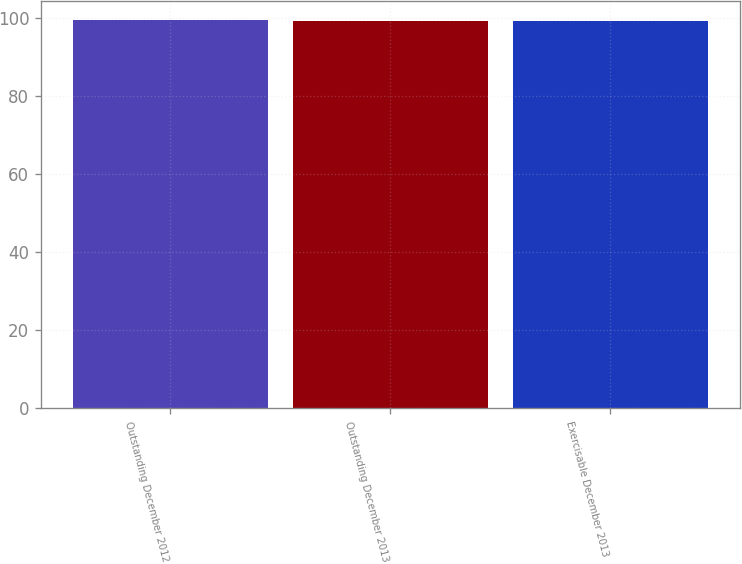Convert chart to OTSL. <chart><loc_0><loc_0><loc_500><loc_500><bar_chart><fcel>Outstanding December 2012<fcel>Outstanding December 2013<fcel>Exercisable December 2013<nl><fcel>99.51<fcel>99.37<fcel>99.38<nl></chart> 